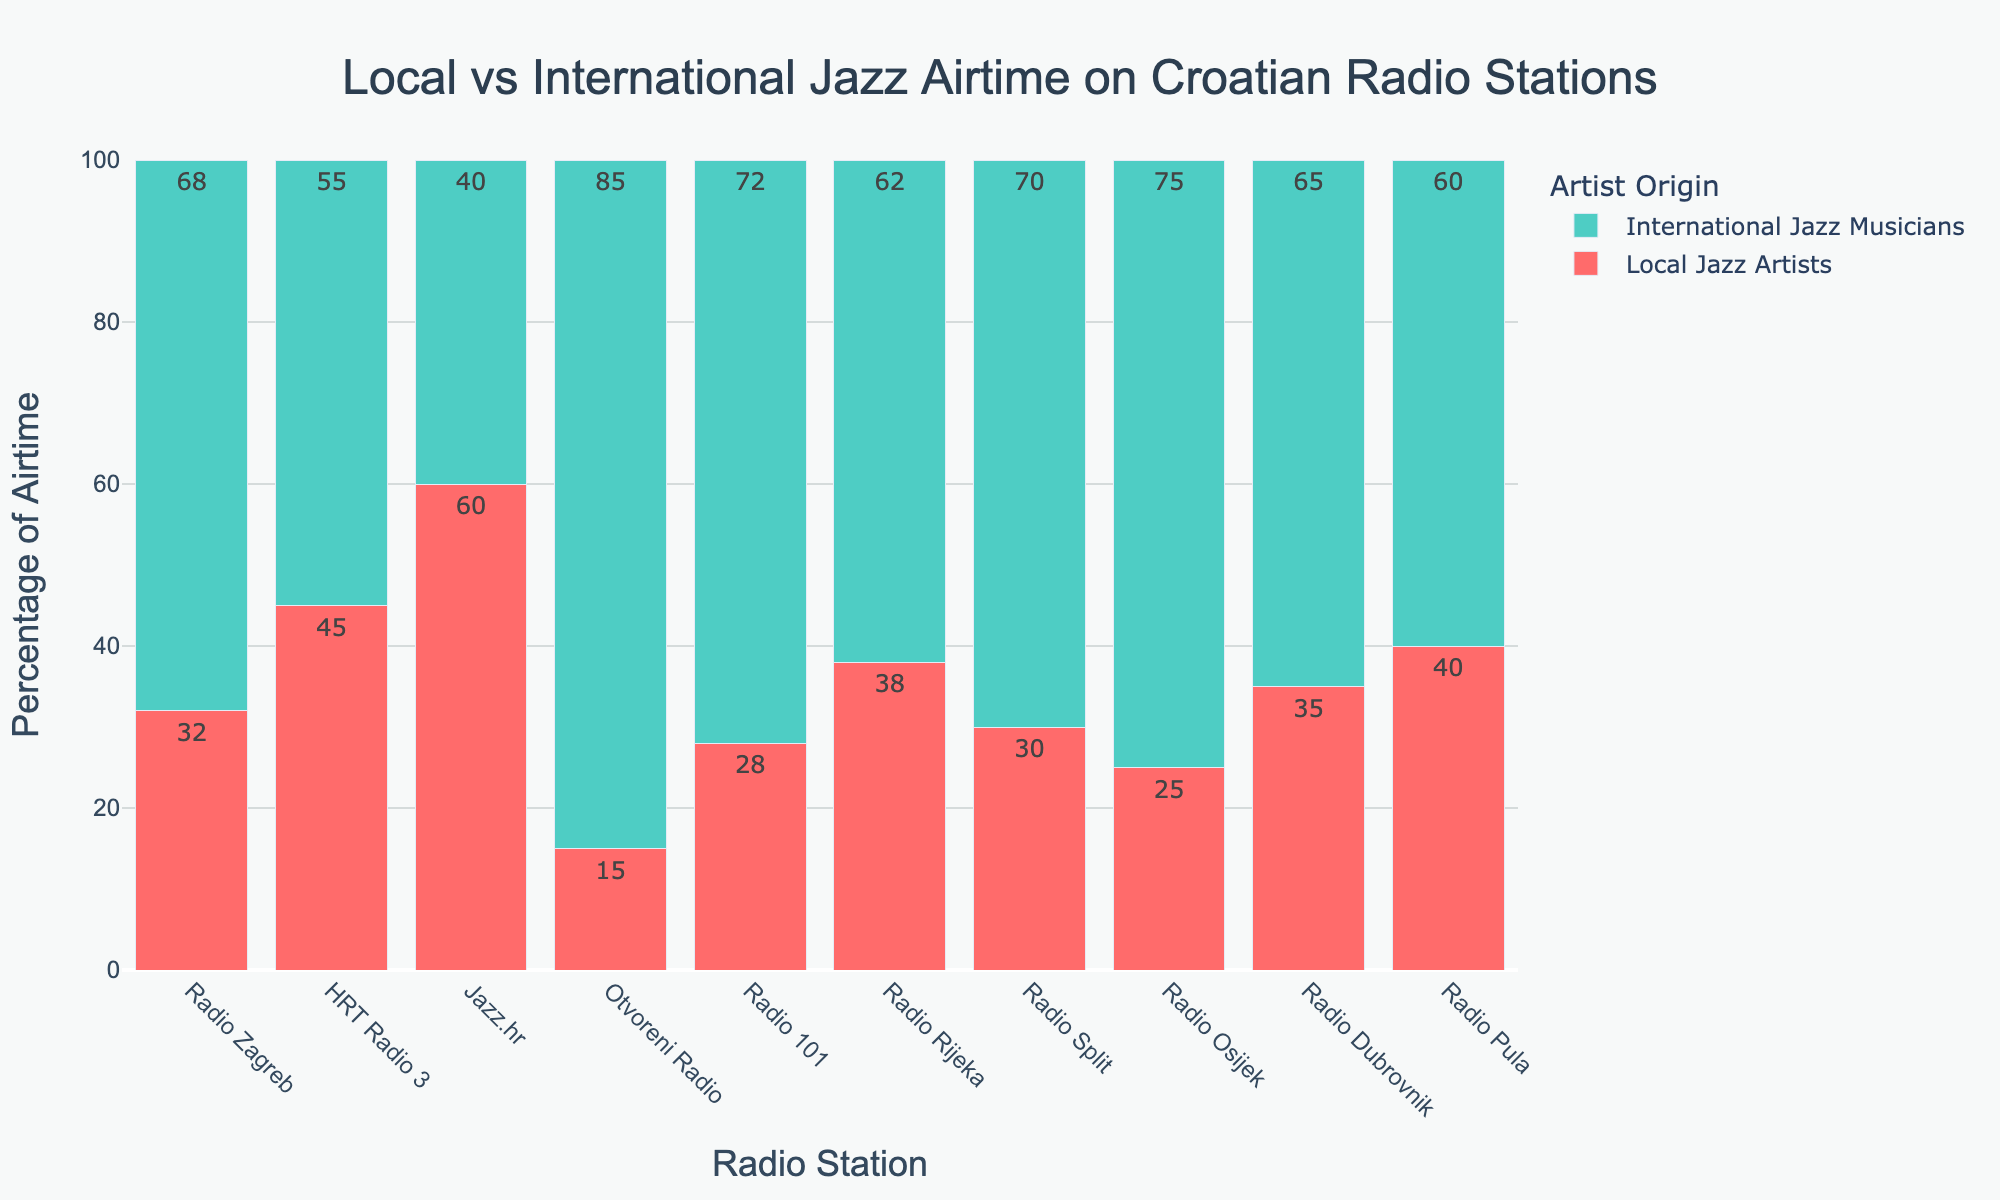Which radio station dedicates the highest percentage of airtime to local jazz artists? The highest percentage of airtime for local jazz artists is indicated by the tallest red bar. Comparing all red bars, Jazz.hr has the tallest red bar at 60%.
Answer: Jazz.hr What is the average percentage of airtime dedicated to international jazz musicians across all radio stations? To find the average percentage, sum the percentages for international jazz musicians and divide by the number of radio stations: (68 + 55 + 40 + 85 + 72 + 62 + 70 + 75 + 65 + 60)/10. This results in 652/10 = 65.2.
Answer: 65.2 Which radio station has the smallest combined airtime percentage for both local and international jazz artists? Each radio station's total percentage sums to 100%, so they all have the same combined airtime of 100%.
Answer: 100 How many radio stations dedicate more than 50% of airtime to international jazz musicians? Check the percentage value of each green bar to see if they exceed 50%. Radio Zagreb, Otvoreni Radio, Radio 101, Radio Split, Radio Osijek, and Radio Dubrovnik all have international airtime percentages above 50%. This counts to 6 radio stations.
Answer: 6 Which radio station has the greatest difference in airtime between local and international jazz musicians? Calculate the absolute difference between local and international airtime for each station: (68-32), (55-45), (60-40), (85-15), (72-28), (62-38), (70-30), (75-25), (65-35), (60-40). The maximum difference is 70 for Otvoreni Radio.
Answer: Otvoreni Radio For how many radio stations is the airtime percentage of local jazz artists greater than 30%? Check each percentage of local jazz artists to see which ones are above 30%. This includes Radio Zagreb, HRT Radio 3, Jazz.hr, Radio Rijeka, Radio Dubrovnik, and Radio Pula, totaling to 6 radio stations.
Answer: 6 By how much does the airtime percentage of local jazz artists on HRT Radio 3 exceed that of Radio Split? The airtime percentage for local jazz artists on HRT Radio 3 is 45%, and on Radio Split, it is 30%. The difference is 45 - 30 = 15.
Answer: 15 What is the median airtime percentage for local jazz artists across all radio stations? Arrange the percentages in ascending order: 15, 25, 28, 30, 32, 35, 38, 40, 45, 60. The median, being the middle value of this ordered list, falls between the 5th and 6th values (32 and 35). Thus, the median is (32 + 35)/2 which is 33.5.
Answer: 33.5 